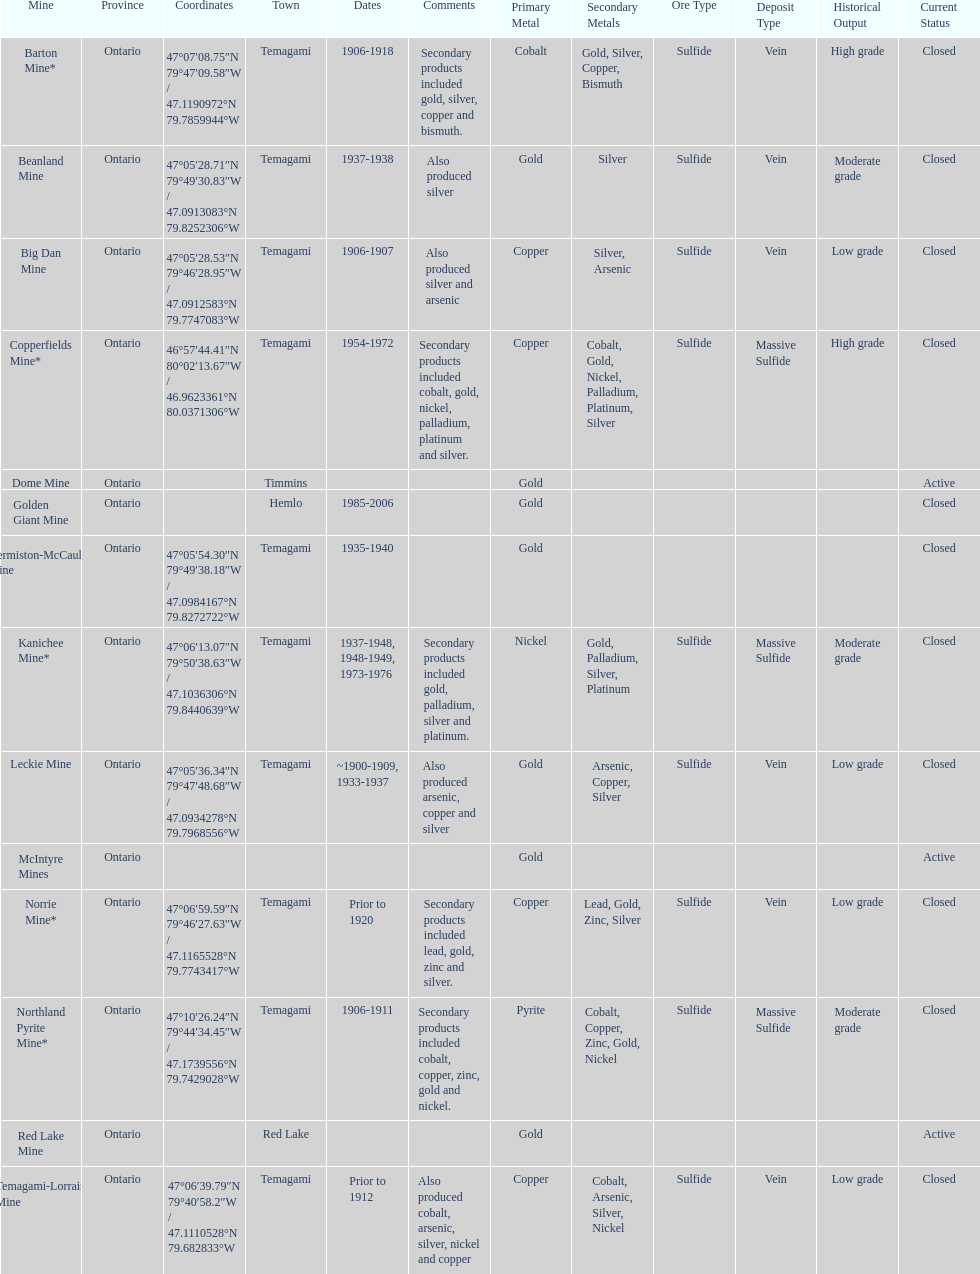What town is listed the most? Temagami. 